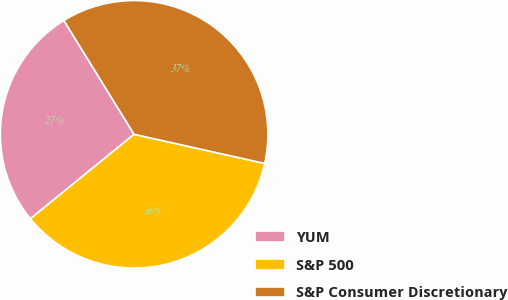Convert chart to OTSL. <chart><loc_0><loc_0><loc_500><loc_500><pie_chart><fcel>YUM<fcel>S&P 500<fcel>S&P Consumer Discretionary<nl><fcel>27.08%<fcel>35.63%<fcel>37.29%<nl></chart> 